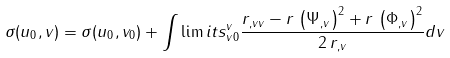Convert formula to latex. <formula><loc_0><loc_0><loc_500><loc_500>\sigma ( u _ { 0 } , v ) = \sigma ( u _ { 0 } , v _ { 0 } ) + \int \lim i t s _ { v 0 } ^ { v } \frac { r _ { , v v } - r \, \left ( \Psi _ { , v } \right ) ^ { 2 } + r \, \left ( \Phi _ { , v } \right ) ^ { 2 } } { 2 \, r _ { , v } } d v</formula> 